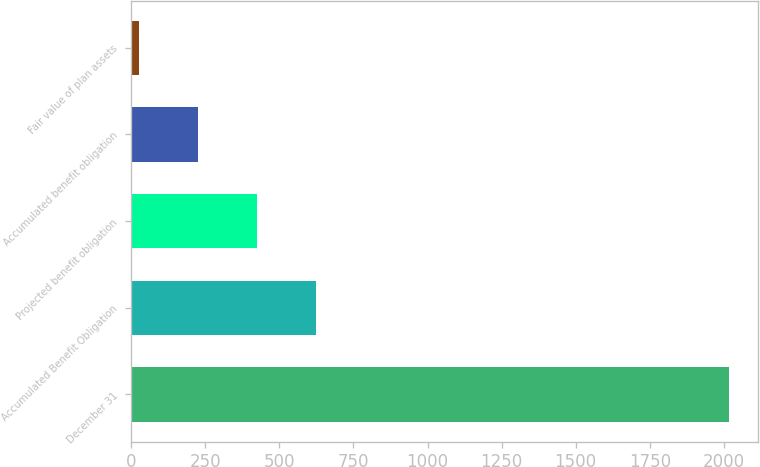Convert chart to OTSL. <chart><loc_0><loc_0><loc_500><loc_500><bar_chart><fcel>December 31<fcel>Accumulated Benefit Obligation<fcel>Projected benefit obligation<fcel>Accumulated benefit obligation<fcel>Fair value of plan assets<nl><fcel>2016<fcel>622.3<fcel>423.2<fcel>224.1<fcel>25<nl></chart> 